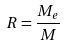Convert formula to latex. <formula><loc_0><loc_0><loc_500><loc_500>R = \frac { M _ { e } } { M }</formula> 